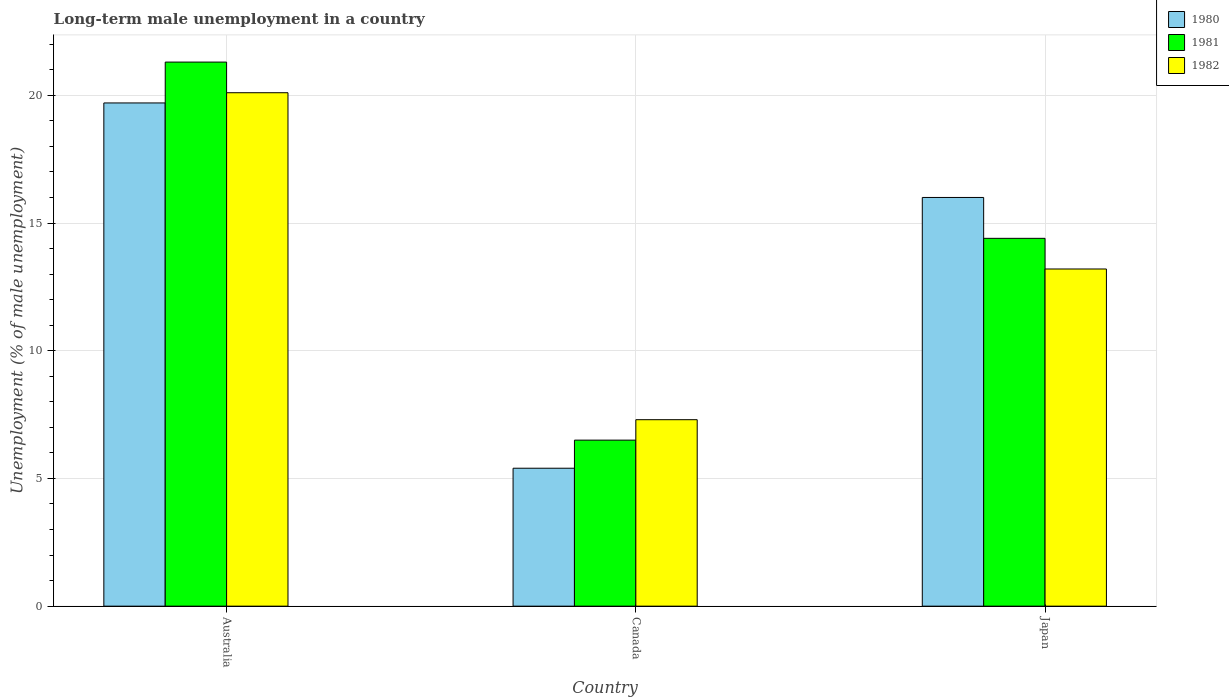Are the number of bars per tick equal to the number of legend labels?
Make the answer very short. Yes. Are the number of bars on each tick of the X-axis equal?
Make the answer very short. Yes. What is the percentage of long-term unemployed male population in 1980 in Japan?
Your answer should be very brief. 16. Across all countries, what is the maximum percentage of long-term unemployed male population in 1981?
Offer a very short reply. 21.3. Across all countries, what is the minimum percentage of long-term unemployed male population in 1980?
Ensure brevity in your answer.  5.4. In which country was the percentage of long-term unemployed male population in 1982 maximum?
Your answer should be very brief. Australia. In which country was the percentage of long-term unemployed male population in 1982 minimum?
Give a very brief answer. Canada. What is the total percentage of long-term unemployed male population in 1980 in the graph?
Your answer should be compact. 41.1. What is the difference between the percentage of long-term unemployed male population in 1981 in Canada and that in Japan?
Give a very brief answer. -7.9. What is the difference between the percentage of long-term unemployed male population in 1981 in Japan and the percentage of long-term unemployed male population in 1982 in Canada?
Keep it short and to the point. 7.1. What is the average percentage of long-term unemployed male population in 1980 per country?
Provide a succinct answer. 13.7. What is the difference between the percentage of long-term unemployed male population of/in 1981 and percentage of long-term unemployed male population of/in 1980 in Japan?
Ensure brevity in your answer.  -1.6. What is the ratio of the percentage of long-term unemployed male population in 1981 in Canada to that in Japan?
Give a very brief answer. 0.45. Is the difference between the percentage of long-term unemployed male population in 1981 in Canada and Japan greater than the difference between the percentage of long-term unemployed male population in 1980 in Canada and Japan?
Give a very brief answer. Yes. What is the difference between the highest and the second highest percentage of long-term unemployed male population in 1980?
Provide a short and direct response. -3.7. What is the difference between the highest and the lowest percentage of long-term unemployed male population in 1982?
Your answer should be compact. 12.8. In how many countries, is the percentage of long-term unemployed male population in 1982 greater than the average percentage of long-term unemployed male population in 1982 taken over all countries?
Your response must be concise. 1. What does the 2nd bar from the left in Canada represents?
Your response must be concise. 1981. Are all the bars in the graph horizontal?
Offer a terse response. No. What is the difference between two consecutive major ticks on the Y-axis?
Provide a succinct answer. 5. Does the graph contain any zero values?
Your response must be concise. No. Where does the legend appear in the graph?
Keep it short and to the point. Top right. How are the legend labels stacked?
Your response must be concise. Vertical. What is the title of the graph?
Offer a terse response. Long-term male unemployment in a country. Does "2005" appear as one of the legend labels in the graph?
Provide a short and direct response. No. What is the label or title of the Y-axis?
Provide a short and direct response. Unemployment (% of male unemployment). What is the Unemployment (% of male unemployment) of 1980 in Australia?
Ensure brevity in your answer.  19.7. What is the Unemployment (% of male unemployment) in 1981 in Australia?
Ensure brevity in your answer.  21.3. What is the Unemployment (% of male unemployment) in 1982 in Australia?
Ensure brevity in your answer.  20.1. What is the Unemployment (% of male unemployment) in 1980 in Canada?
Your answer should be compact. 5.4. What is the Unemployment (% of male unemployment) in 1981 in Canada?
Give a very brief answer. 6.5. What is the Unemployment (% of male unemployment) in 1982 in Canada?
Provide a succinct answer. 7.3. What is the Unemployment (% of male unemployment) in 1981 in Japan?
Make the answer very short. 14.4. What is the Unemployment (% of male unemployment) of 1982 in Japan?
Give a very brief answer. 13.2. Across all countries, what is the maximum Unemployment (% of male unemployment) in 1980?
Ensure brevity in your answer.  19.7. Across all countries, what is the maximum Unemployment (% of male unemployment) of 1981?
Your answer should be very brief. 21.3. Across all countries, what is the maximum Unemployment (% of male unemployment) in 1982?
Your response must be concise. 20.1. Across all countries, what is the minimum Unemployment (% of male unemployment) of 1980?
Provide a short and direct response. 5.4. Across all countries, what is the minimum Unemployment (% of male unemployment) of 1981?
Your answer should be very brief. 6.5. Across all countries, what is the minimum Unemployment (% of male unemployment) of 1982?
Offer a very short reply. 7.3. What is the total Unemployment (% of male unemployment) of 1980 in the graph?
Your response must be concise. 41.1. What is the total Unemployment (% of male unemployment) of 1981 in the graph?
Your answer should be very brief. 42.2. What is the total Unemployment (% of male unemployment) of 1982 in the graph?
Keep it short and to the point. 40.6. What is the difference between the Unemployment (% of male unemployment) in 1980 in Australia and that in Canada?
Ensure brevity in your answer.  14.3. What is the difference between the Unemployment (% of male unemployment) in 1982 in Australia and that in Canada?
Provide a succinct answer. 12.8. What is the difference between the Unemployment (% of male unemployment) of 1981 in Australia and that in Japan?
Your answer should be very brief. 6.9. What is the difference between the Unemployment (% of male unemployment) in 1982 in Australia and that in Japan?
Make the answer very short. 6.9. What is the difference between the Unemployment (% of male unemployment) of 1982 in Canada and that in Japan?
Give a very brief answer. -5.9. What is the difference between the Unemployment (% of male unemployment) in 1980 in Australia and the Unemployment (% of male unemployment) in 1981 in Canada?
Your answer should be very brief. 13.2. What is the difference between the Unemployment (% of male unemployment) in 1981 in Australia and the Unemployment (% of male unemployment) in 1982 in Canada?
Offer a very short reply. 14. What is the difference between the Unemployment (% of male unemployment) in 1980 in Australia and the Unemployment (% of male unemployment) in 1981 in Japan?
Keep it short and to the point. 5.3. What is the difference between the Unemployment (% of male unemployment) in 1980 in Australia and the Unemployment (% of male unemployment) in 1982 in Japan?
Your response must be concise. 6.5. What is the difference between the Unemployment (% of male unemployment) in 1981 in Australia and the Unemployment (% of male unemployment) in 1982 in Japan?
Offer a very short reply. 8.1. What is the difference between the Unemployment (% of male unemployment) in 1980 in Canada and the Unemployment (% of male unemployment) in 1981 in Japan?
Keep it short and to the point. -9. What is the difference between the Unemployment (% of male unemployment) in 1980 in Canada and the Unemployment (% of male unemployment) in 1982 in Japan?
Provide a succinct answer. -7.8. What is the average Unemployment (% of male unemployment) in 1980 per country?
Ensure brevity in your answer.  13.7. What is the average Unemployment (% of male unemployment) of 1981 per country?
Offer a very short reply. 14.07. What is the average Unemployment (% of male unemployment) in 1982 per country?
Give a very brief answer. 13.53. What is the difference between the Unemployment (% of male unemployment) of 1980 and Unemployment (% of male unemployment) of 1981 in Australia?
Your answer should be compact. -1.6. What is the difference between the Unemployment (% of male unemployment) of 1980 and Unemployment (% of male unemployment) of 1981 in Canada?
Give a very brief answer. -1.1. What is the difference between the Unemployment (% of male unemployment) in 1981 and Unemployment (% of male unemployment) in 1982 in Canada?
Offer a very short reply. -0.8. What is the difference between the Unemployment (% of male unemployment) in 1980 and Unemployment (% of male unemployment) in 1982 in Japan?
Offer a very short reply. 2.8. What is the difference between the Unemployment (% of male unemployment) in 1981 and Unemployment (% of male unemployment) in 1982 in Japan?
Offer a terse response. 1.2. What is the ratio of the Unemployment (% of male unemployment) in 1980 in Australia to that in Canada?
Your response must be concise. 3.65. What is the ratio of the Unemployment (% of male unemployment) in 1981 in Australia to that in Canada?
Ensure brevity in your answer.  3.28. What is the ratio of the Unemployment (% of male unemployment) in 1982 in Australia to that in Canada?
Your answer should be very brief. 2.75. What is the ratio of the Unemployment (% of male unemployment) in 1980 in Australia to that in Japan?
Make the answer very short. 1.23. What is the ratio of the Unemployment (% of male unemployment) of 1981 in Australia to that in Japan?
Offer a terse response. 1.48. What is the ratio of the Unemployment (% of male unemployment) of 1982 in Australia to that in Japan?
Ensure brevity in your answer.  1.52. What is the ratio of the Unemployment (% of male unemployment) of 1980 in Canada to that in Japan?
Make the answer very short. 0.34. What is the ratio of the Unemployment (% of male unemployment) in 1981 in Canada to that in Japan?
Ensure brevity in your answer.  0.45. What is the ratio of the Unemployment (% of male unemployment) of 1982 in Canada to that in Japan?
Keep it short and to the point. 0.55. What is the difference between the highest and the second highest Unemployment (% of male unemployment) of 1981?
Offer a terse response. 6.9. What is the difference between the highest and the second highest Unemployment (% of male unemployment) of 1982?
Keep it short and to the point. 6.9. What is the difference between the highest and the lowest Unemployment (% of male unemployment) of 1980?
Provide a succinct answer. 14.3. 